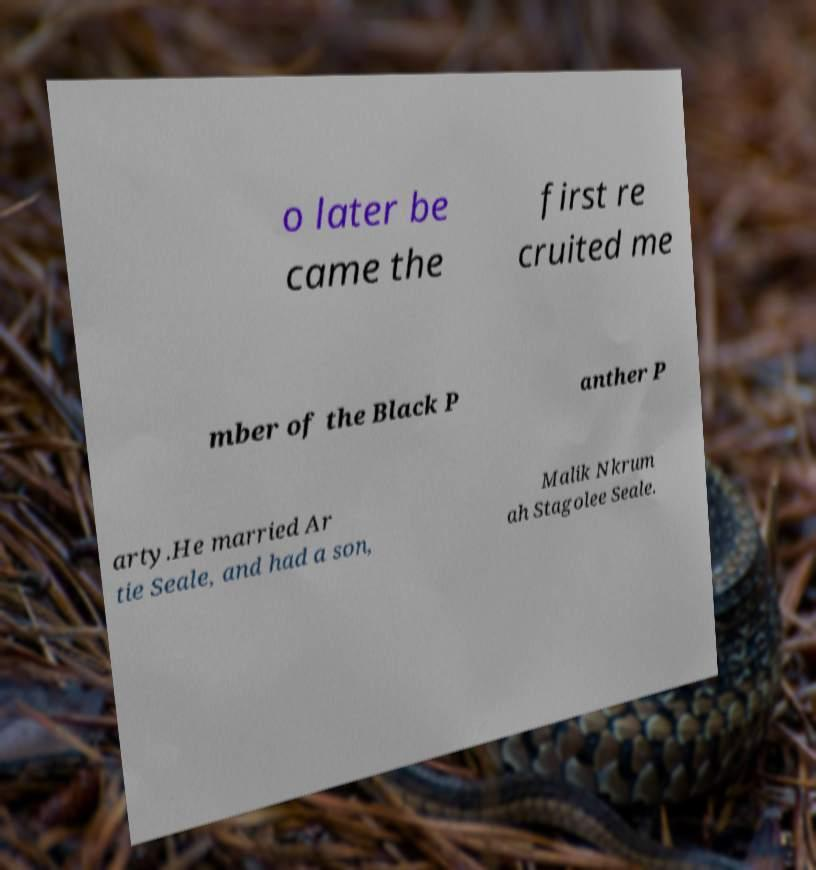Could you extract and type out the text from this image? o later be came the first re cruited me mber of the Black P anther P arty.He married Ar tie Seale, and had a son, Malik Nkrum ah Stagolee Seale. 